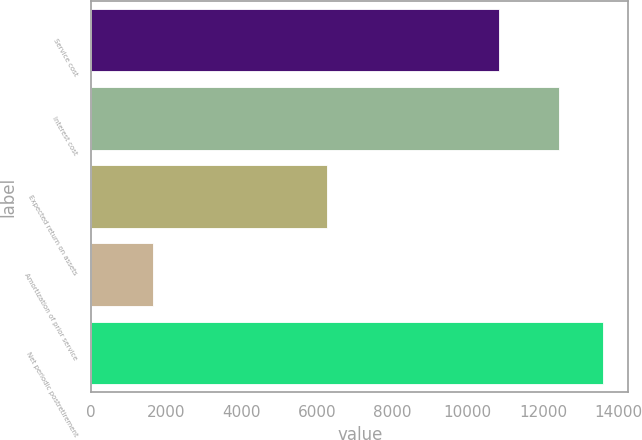Convert chart. <chart><loc_0><loc_0><loc_500><loc_500><bar_chart><fcel>Service cost<fcel>Interest cost<fcel>Expected return on assets<fcel>Amortization of prior service<fcel>Net periodic postretirement<nl><fcel>10823<fcel>12424<fcel>6264<fcel>1644<fcel>13585<nl></chart> 